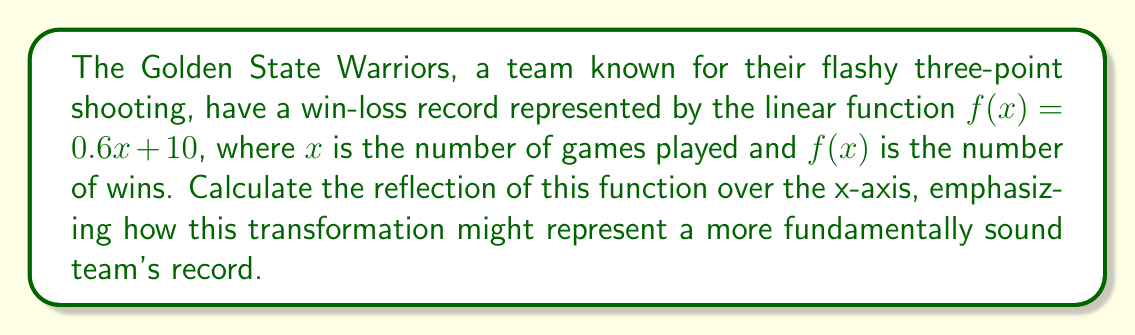Teach me how to tackle this problem. To reflect a function over the x-axis, we need to negate the y-values. This means multiplying the entire function by -1. Let's go through this step-by-step:

1) The original function is $f(x) = 0.6x + 10$

2) To reflect over the x-axis, we multiply the entire function by -1:
   $g(x) = -1 \cdot f(x) = -1 \cdot (0.6x + 10)$

3) Distribute the negative sign:
   $g(x) = -0.6x - 10$

4) This new function $g(x)$ represents the reflection of the original function over the x-axis.

5) Interpretation: 
   - The original slope of 0.6 indicates the team wins 60% of their games.
   - The reflected slope of -0.6 could represent a team that loses 60% of their games.
   - The y-intercept changing from +10 to -10 might indicate a team starting with a 10-game losing streak instead of a 10-game winning streak.

This transformation could represent a more fundamentally sound team that starts slow but gradually improves over the season, as opposed to a flashy team that starts strong but may not maintain their performance.
Answer: $g(x) = -0.6x - 10$ 